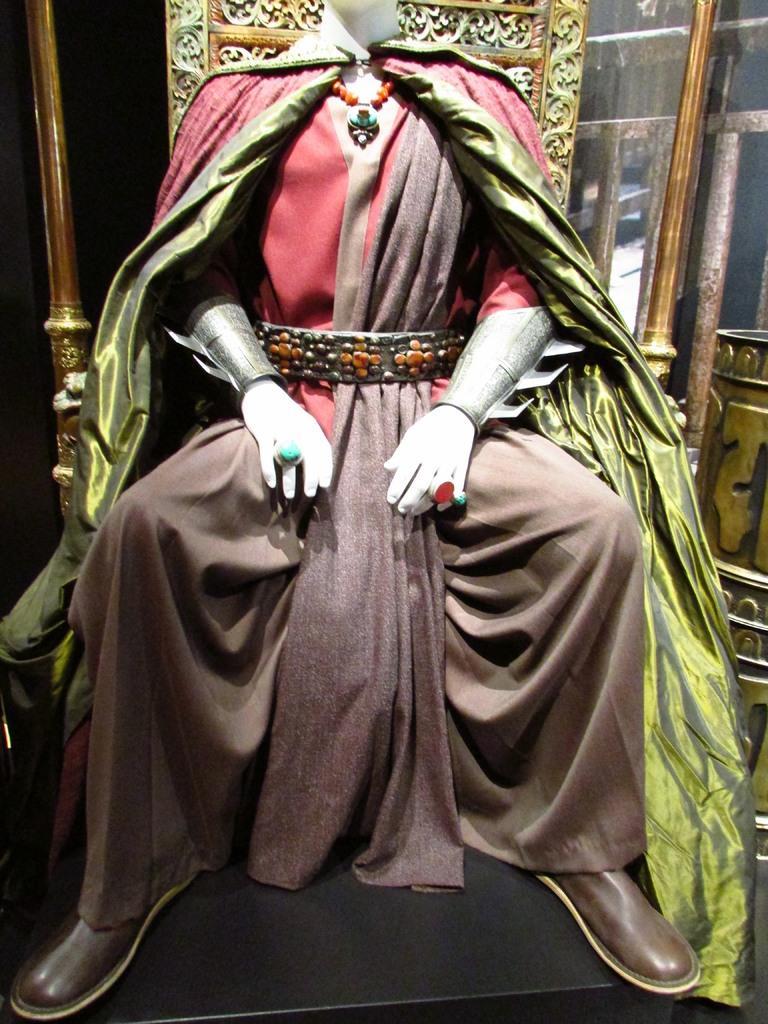Can you describe this image briefly? In this picture we can see a statue of a person wore ornaments and sitting on a chair, cloth and in the background we can see some objects. 